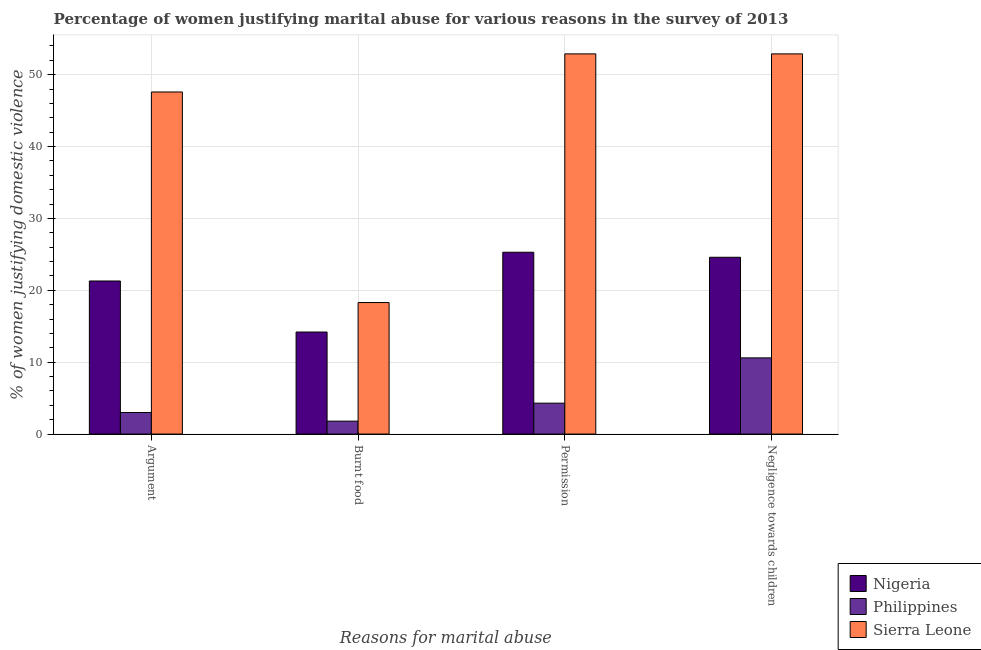How many different coloured bars are there?
Your answer should be very brief. 3. How many groups of bars are there?
Offer a very short reply. 4. What is the label of the 1st group of bars from the left?
Ensure brevity in your answer.  Argument. Across all countries, what is the maximum percentage of women justifying abuse for going without permission?
Your answer should be very brief. 52.9. Across all countries, what is the minimum percentage of women justifying abuse for showing negligence towards children?
Provide a succinct answer. 10.6. In which country was the percentage of women justifying abuse in the case of an argument maximum?
Provide a short and direct response. Sierra Leone. What is the total percentage of women justifying abuse for showing negligence towards children in the graph?
Give a very brief answer. 88.1. What is the difference between the percentage of women justifying abuse for burning food in Nigeria and that in Philippines?
Your answer should be compact. 12.4. What is the difference between the percentage of women justifying abuse for burning food in Nigeria and the percentage of women justifying abuse for showing negligence towards children in Sierra Leone?
Provide a short and direct response. -38.7. What is the difference between the percentage of women justifying abuse for showing negligence towards children and percentage of women justifying abuse for going without permission in Sierra Leone?
Your response must be concise. 0. In how many countries, is the percentage of women justifying abuse for showing negligence towards children greater than 2 %?
Your response must be concise. 3. What is the ratio of the percentage of women justifying abuse for going without permission in Nigeria to that in Philippines?
Provide a short and direct response. 5.88. Is the difference between the percentage of women justifying abuse for going without permission in Sierra Leone and Philippines greater than the difference between the percentage of women justifying abuse for showing negligence towards children in Sierra Leone and Philippines?
Make the answer very short. Yes. What is the difference between the highest and the second highest percentage of women justifying abuse for going without permission?
Your response must be concise. 27.6. What is the difference between the highest and the lowest percentage of women justifying abuse for going without permission?
Keep it short and to the point. 48.6. In how many countries, is the percentage of women justifying abuse for going without permission greater than the average percentage of women justifying abuse for going without permission taken over all countries?
Make the answer very short. 1. Is the sum of the percentage of women justifying abuse for going without permission in Sierra Leone and Nigeria greater than the maximum percentage of women justifying abuse for burning food across all countries?
Ensure brevity in your answer.  Yes. Is it the case that in every country, the sum of the percentage of women justifying abuse for burning food and percentage of women justifying abuse in the case of an argument is greater than the sum of percentage of women justifying abuse for going without permission and percentage of women justifying abuse for showing negligence towards children?
Provide a succinct answer. No. What does the 1st bar from the left in Argument represents?
Offer a terse response. Nigeria. What does the 1st bar from the right in Burnt food represents?
Your answer should be very brief. Sierra Leone. Is it the case that in every country, the sum of the percentage of women justifying abuse in the case of an argument and percentage of women justifying abuse for burning food is greater than the percentage of women justifying abuse for going without permission?
Offer a terse response. Yes. How many bars are there?
Offer a very short reply. 12. How many countries are there in the graph?
Offer a very short reply. 3. What is the difference between two consecutive major ticks on the Y-axis?
Ensure brevity in your answer.  10. Are the values on the major ticks of Y-axis written in scientific E-notation?
Make the answer very short. No. Where does the legend appear in the graph?
Your answer should be very brief. Bottom right. What is the title of the graph?
Your answer should be very brief. Percentage of women justifying marital abuse for various reasons in the survey of 2013. Does "Qatar" appear as one of the legend labels in the graph?
Offer a very short reply. No. What is the label or title of the X-axis?
Your answer should be very brief. Reasons for marital abuse. What is the label or title of the Y-axis?
Your answer should be compact. % of women justifying domestic violence. What is the % of women justifying domestic violence in Nigeria in Argument?
Provide a succinct answer. 21.3. What is the % of women justifying domestic violence in Sierra Leone in Argument?
Your answer should be very brief. 47.6. What is the % of women justifying domestic violence in Philippines in Burnt food?
Provide a succinct answer. 1.8. What is the % of women justifying domestic violence of Sierra Leone in Burnt food?
Your answer should be very brief. 18.3. What is the % of women justifying domestic violence in Nigeria in Permission?
Offer a terse response. 25.3. What is the % of women justifying domestic violence in Philippines in Permission?
Offer a very short reply. 4.3. What is the % of women justifying domestic violence in Sierra Leone in Permission?
Ensure brevity in your answer.  52.9. What is the % of women justifying domestic violence in Nigeria in Negligence towards children?
Your response must be concise. 24.6. What is the % of women justifying domestic violence of Sierra Leone in Negligence towards children?
Your response must be concise. 52.9. Across all Reasons for marital abuse, what is the maximum % of women justifying domestic violence in Nigeria?
Make the answer very short. 25.3. Across all Reasons for marital abuse, what is the maximum % of women justifying domestic violence in Philippines?
Ensure brevity in your answer.  10.6. Across all Reasons for marital abuse, what is the maximum % of women justifying domestic violence in Sierra Leone?
Offer a terse response. 52.9. Across all Reasons for marital abuse, what is the minimum % of women justifying domestic violence in Nigeria?
Your answer should be compact. 14.2. Across all Reasons for marital abuse, what is the minimum % of women justifying domestic violence of Philippines?
Make the answer very short. 1.8. What is the total % of women justifying domestic violence in Nigeria in the graph?
Your answer should be very brief. 85.4. What is the total % of women justifying domestic violence of Philippines in the graph?
Your response must be concise. 19.7. What is the total % of women justifying domestic violence of Sierra Leone in the graph?
Your response must be concise. 171.7. What is the difference between the % of women justifying domestic violence in Nigeria in Argument and that in Burnt food?
Your response must be concise. 7.1. What is the difference between the % of women justifying domestic violence of Philippines in Argument and that in Burnt food?
Your answer should be compact. 1.2. What is the difference between the % of women justifying domestic violence of Sierra Leone in Argument and that in Burnt food?
Ensure brevity in your answer.  29.3. What is the difference between the % of women justifying domestic violence in Philippines in Argument and that in Permission?
Provide a short and direct response. -1.3. What is the difference between the % of women justifying domestic violence of Nigeria in Burnt food and that in Permission?
Your response must be concise. -11.1. What is the difference between the % of women justifying domestic violence in Sierra Leone in Burnt food and that in Permission?
Your response must be concise. -34.6. What is the difference between the % of women justifying domestic violence in Nigeria in Burnt food and that in Negligence towards children?
Provide a short and direct response. -10.4. What is the difference between the % of women justifying domestic violence in Philippines in Burnt food and that in Negligence towards children?
Give a very brief answer. -8.8. What is the difference between the % of women justifying domestic violence of Sierra Leone in Burnt food and that in Negligence towards children?
Your answer should be compact. -34.6. What is the difference between the % of women justifying domestic violence of Nigeria in Permission and that in Negligence towards children?
Provide a succinct answer. 0.7. What is the difference between the % of women justifying domestic violence of Philippines in Permission and that in Negligence towards children?
Your response must be concise. -6.3. What is the difference between the % of women justifying domestic violence in Nigeria in Argument and the % of women justifying domestic violence in Sierra Leone in Burnt food?
Offer a very short reply. 3. What is the difference between the % of women justifying domestic violence in Philippines in Argument and the % of women justifying domestic violence in Sierra Leone in Burnt food?
Provide a short and direct response. -15.3. What is the difference between the % of women justifying domestic violence in Nigeria in Argument and the % of women justifying domestic violence in Sierra Leone in Permission?
Offer a terse response. -31.6. What is the difference between the % of women justifying domestic violence in Philippines in Argument and the % of women justifying domestic violence in Sierra Leone in Permission?
Provide a short and direct response. -49.9. What is the difference between the % of women justifying domestic violence of Nigeria in Argument and the % of women justifying domestic violence of Philippines in Negligence towards children?
Your answer should be very brief. 10.7. What is the difference between the % of women justifying domestic violence in Nigeria in Argument and the % of women justifying domestic violence in Sierra Leone in Negligence towards children?
Ensure brevity in your answer.  -31.6. What is the difference between the % of women justifying domestic violence in Philippines in Argument and the % of women justifying domestic violence in Sierra Leone in Negligence towards children?
Provide a short and direct response. -49.9. What is the difference between the % of women justifying domestic violence in Nigeria in Burnt food and the % of women justifying domestic violence in Sierra Leone in Permission?
Ensure brevity in your answer.  -38.7. What is the difference between the % of women justifying domestic violence of Philippines in Burnt food and the % of women justifying domestic violence of Sierra Leone in Permission?
Provide a short and direct response. -51.1. What is the difference between the % of women justifying domestic violence in Nigeria in Burnt food and the % of women justifying domestic violence in Philippines in Negligence towards children?
Give a very brief answer. 3.6. What is the difference between the % of women justifying domestic violence in Nigeria in Burnt food and the % of women justifying domestic violence in Sierra Leone in Negligence towards children?
Make the answer very short. -38.7. What is the difference between the % of women justifying domestic violence of Philippines in Burnt food and the % of women justifying domestic violence of Sierra Leone in Negligence towards children?
Your response must be concise. -51.1. What is the difference between the % of women justifying domestic violence of Nigeria in Permission and the % of women justifying domestic violence of Sierra Leone in Negligence towards children?
Your answer should be very brief. -27.6. What is the difference between the % of women justifying domestic violence in Philippines in Permission and the % of women justifying domestic violence in Sierra Leone in Negligence towards children?
Offer a terse response. -48.6. What is the average % of women justifying domestic violence in Nigeria per Reasons for marital abuse?
Keep it short and to the point. 21.35. What is the average % of women justifying domestic violence of Philippines per Reasons for marital abuse?
Ensure brevity in your answer.  4.92. What is the average % of women justifying domestic violence of Sierra Leone per Reasons for marital abuse?
Provide a short and direct response. 42.92. What is the difference between the % of women justifying domestic violence in Nigeria and % of women justifying domestic violence in Sierra Leone in Argument?
Make the answer very short. -26.3. What is the difference between the % of women justifying domestic violence of Philippines and % of women justifying domestic violence of Sierra Leone in Argument?
Keep it short and to the point. -44.6. What is the difference between the % of women justifying domestic violence in Philippines and % of women justifying domestic violence in Sierra Leone in Burnt food?
Provide a succinct answer. -16.5. What is the difference between the % of women justifying domestic violence of Nigeria and % of women justifying domestic violence of Sierra Leone in Permission?
Give a very brief answer. -27.6. What is the difference between the % of women justifying domestic violence of Philippines and % of women justifying domestic violence of Sierra Leone in Permission?
Your response must be concise. -48.6. What is the difference between the % of women justifying domestic violence of Nigeria and % of women justifying domestic violence of Sierra Leone in Negligence towards children?
Your response must be concise. -28.3. What is the difference between the % of women justifying domestic violence of Philippines and % of women justifying domestic violence of Sierra Leone in Negligence towards children?
Ensure brevity in your answer.  -42.3. What is the ratio of the % of women justifying domestic violence of Philippines in Argument to that in Burnt food?
Your answer should be compact. 1.67. What is the ratio of the % of women justifying domestic violence in Sierra Leone in Argument to that in Burnt food?
Provide a short and direct response. 2.6. What is the ratio of the % of women justifying domestic violence of Nigeria in Argument to that in Permission?
Provide a succinct answer. 0.84. What is the ratio of the % of women justifying domestic violence in Philippines in Argument to that in Permission?
Keep it short and to the point. 0.7. What is the ratio of the % of women justifying domestic violence in Sierra Leone in Argument to that in Permission?
Keep it short and to the point. 0.9. What is the ratio of the % of women justifying domestic violence in Nigeria in Argument to that in Negligence towards children?
Offer a very short reply. 0.87. What is the ratio of the % of women justifying domestic violence in Philippines in Argument to that in Negligence towards children?
Offer a very short reply. 0.28. What is the ratio of the % of women justifying domestic violence in Sierra Leone in Argument to that in Negligence towards children?
Provide a short and direct response. 0.9. What is the ratio of the % of women justifying domestic violence in Nigeria in Burnt food to that in Permission?
Offer a very short reply. 0.56. What is the ratio of the % of women justifying domestic violence of Philippines in Burnt food to that in Permission?
Your answer should be very brief. 0.42. What is the ratio of the % of women justifying domestic violence of Sierra Leone in Burnt food to that in Permission?
Give a very brief answer. 0.35. What is the ratio of the % of women justifying domestic violence in Nigeria in Burnt food to that in Negligence towards children?
Offer a very short reply. 0.58. What is the ratio of the % of women justifying domestic violence of Philippines in Burnt food to that in Negligence towards children?
Your answer should be very brief. 0.17. What is the ratio of the % of women justifying domestic violence in Sierra Leone in Burnt food to that in Negligence towards children?
Your answer should be very brief. 0.35. What is the ratio of the % of women justifying domestic violence in Nigeria in Permission to that in Negligence towards children?
Provide a short and direct response. 1.03. What is the ratio of the % of women justifying domestic violence of Philippines in Permission to that in Negligence towards children?
Provide a succinct answer. 0.41. What is the ratio of the % of women justifying domestic violence of Sierra Leone in Permission to that in Negligence towards children?
Your answer should be very brief. 1. What is the difference between the highest and the second highest % of women justifying domestic violence in Nigeria?
Your answer should be compact. 0.7. What is the difference between the highest and the lowest % of women justifying domestic violence of Philippines?
Your answer should be very brief. 8.8. What is the difference between the highest and the lowest % of women justifying domestic violence of Sierra Leone?
Provide a succinct answer. 34.6. 